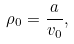Convert formula to latex. <formula><loc_0><loc_0><loc_500><loc_500>\rho _ { 0 } = \frac { a } { v _ { 0 } } ,</formula> 